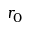<formula> <loc_0><loc_0><loc_500><loc_500>r _ { 0 }</formula> 